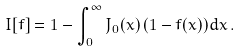Convert formula to latex. <formula><loc_0><loc_0><loc_500><loc_500>I [ f ] = 1 - \int _ { 0 } ^ { \infty } J _ { 0 } ( x ) \, ( 1 - f ( x ) ) d x \, .</formula> 